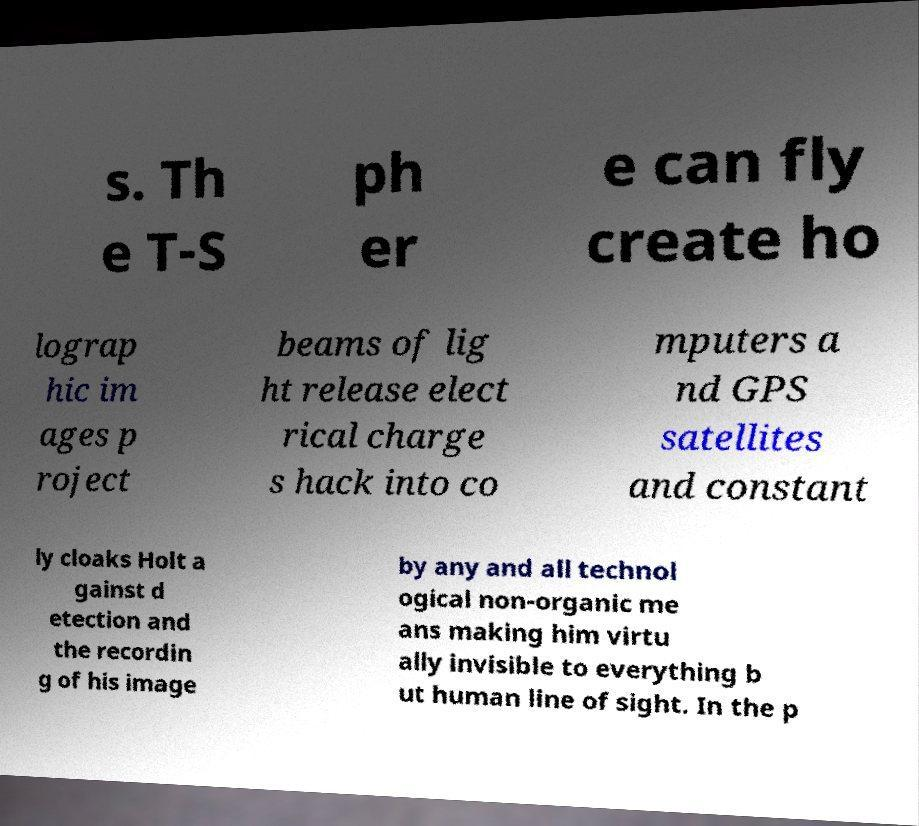Could you extract and type out the text from this image? s. Th e T-S ph er e can fly create ho lograp hic im ages p roject beams of lig ht release elect rical charge s hack into co mputers a nd GPS satellites and constant ly cloaks Holt a gainst d etection and the recordin g of his image by any and all technol ogical non-organic me ans making him virtu ally invisible to everything b ut human line of sight. In the p 